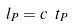Convert formula to latex. <formula><loc_0><loc_0><loc_500><loc_500>l _ { P } = c \ t _ { P }</formula> 